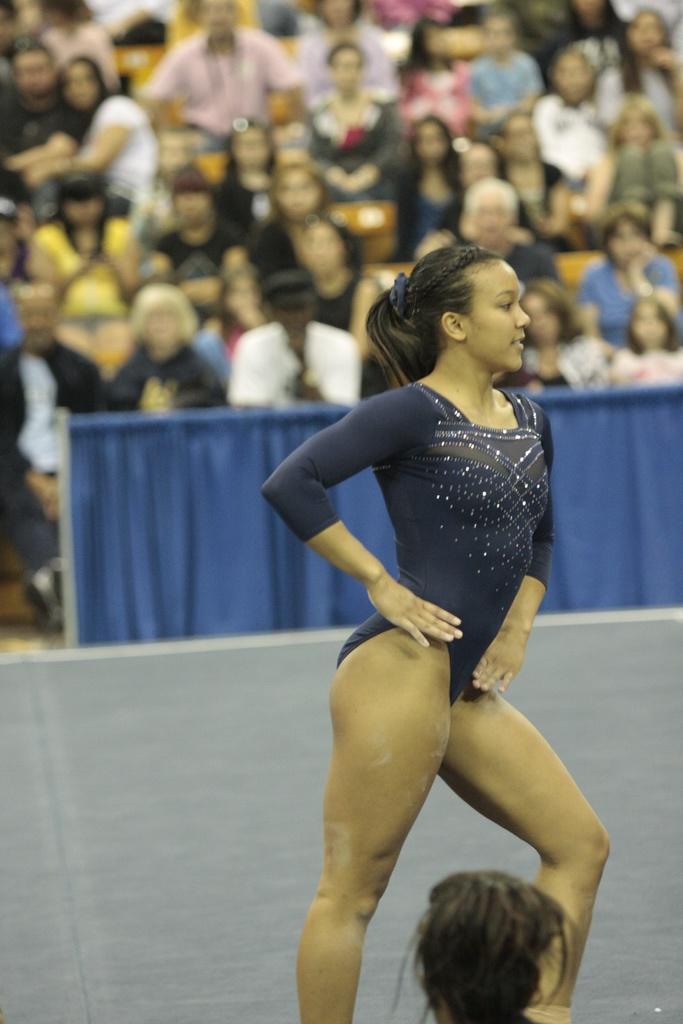In one or two sentences, can you explain what this image depicts? In this image we can see a woman wearing a blue color dress is stunning. The background of the image is slightly blurred, where we can see a few more people sitting in the stadium and we can see the blue color clothes. 